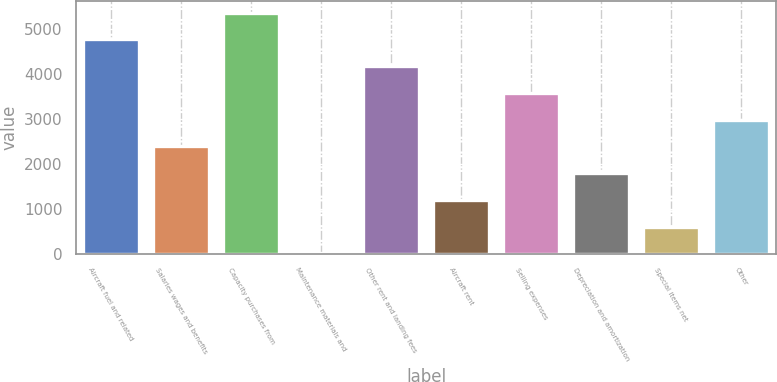Convert chart. <chart><loc_0><loc_0><loc_500><loc_500><bar_chart><fcel>Aircraft fuel and related<fcel>Salaries wages and benefits<fcel>Capacity purchases from<fcel>Maintenance materials and<fcel>Other rent and landing fees<fcel>Aircraft rent<fcel>Selling expenses<fcel>Depreciation and amortization<fcel>Special items net<fcel>Other<nl><fcel>4762.4<fcel>2383.2<fcel>5357.2<fcel>4<fcel>4167.6<fcel>1193.6<fcel>3572.8<fcel>1788.4<fcel>598.8<fcel>2978<nl></chart> 